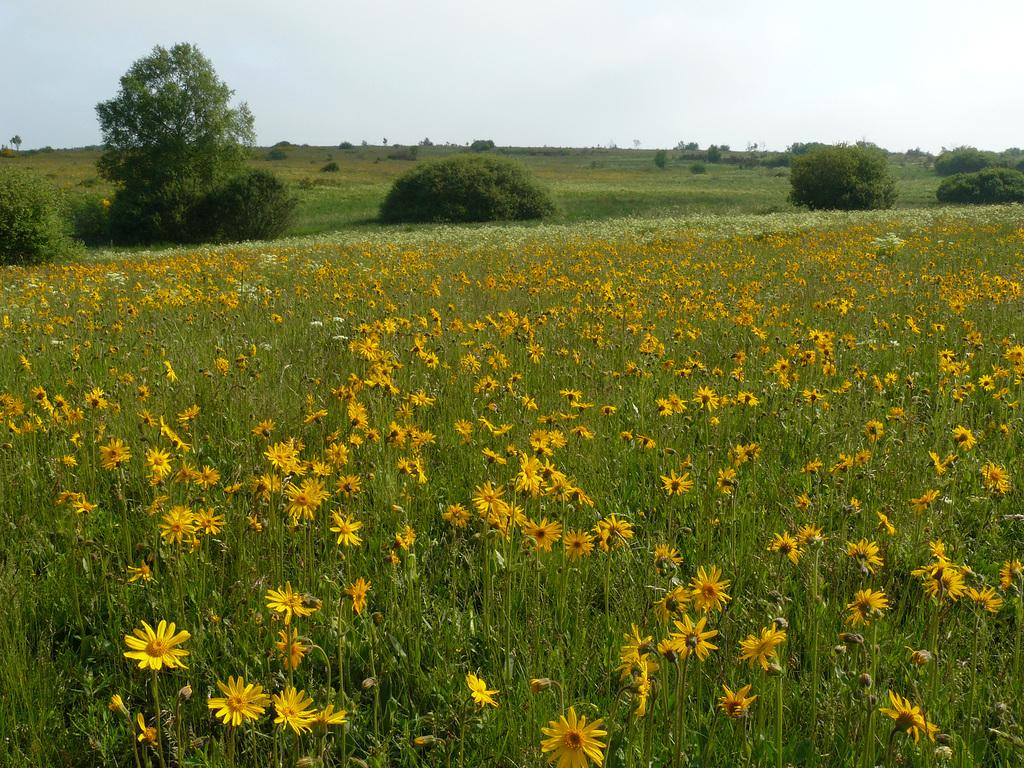What type of vegetation can be seen in the image? There are flowers, plants, and trees visible in the image. What is visible in the background of the image? The sky is visible in the background of the image. What type of border is present around the flowers in the image? There is no border present around the flowers in the image. What message of hope can be seen in the image? There is no message or text present in the image, so it cannot convey a message of hope. 